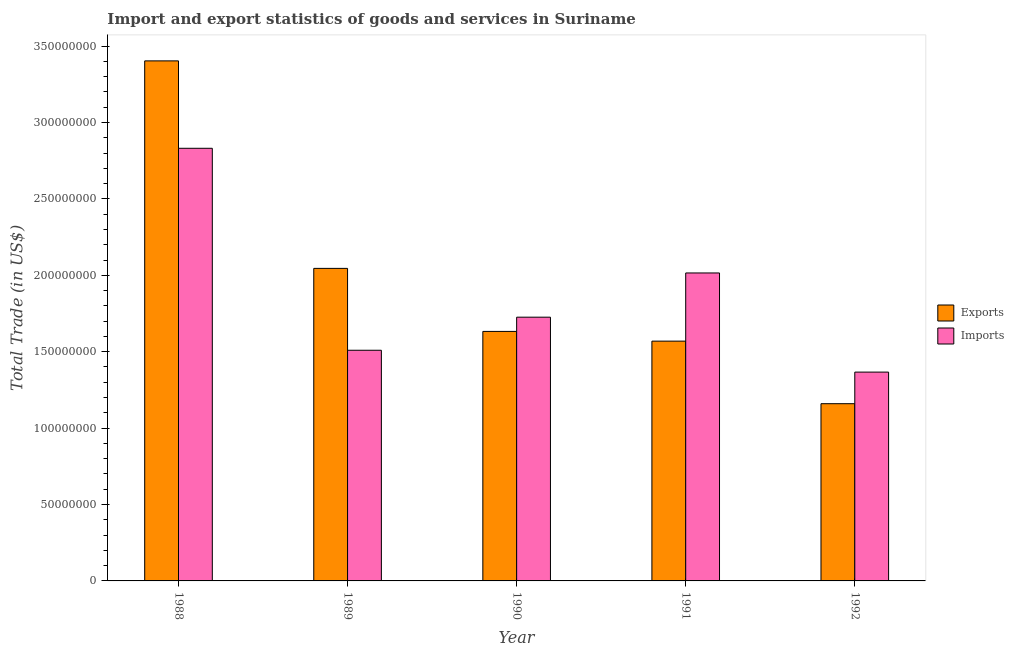How many groups of bars are there?
Your answer should be very brief. 5. Are the number of bars on each tick of the X-axis equal?
Give a very brief answer. Yes. How many bars are there on the 3rd tick from the left?
Make the answer very short. 2. What is the label of the 1st group of bars from the left?
Provide a succinct answer. 1988. In how many cases, is the number of bars for a given year not equal to the number of legend labels?
Ensure brevity in your answer.  0. What is the export of goods and services in 1989?
Your answer should be very brief. 2.05e+08. Across all years, what is the maximum imports of goods and services?
Ensure brevity in your answer.  2.83e+08. Across all years, what is the minimum imports of goods and services?
Offer a terse response. 1.37e+08. In which year was the imports of goods and services maximum?
Provide a short and direct response. 1988. What is the total imports of goods and services in the graph?
Make the answer very short. 9.45e+08. What is the difference between the export of goods and services in 1990 and that in 1991?
Provide a succinct answer. 6.36e+06. What is the difference between the export of goods and services in 1988 and the imports of goods and services in 1989?
Provide a succinct answer. 1.36e+08. What is the average export of goods and services per year?
Make the answer very short. 1.96e+08. In the year 1988, what is the difference between the imports of goods and services and export of goods and services?
Your answer should be compact. 0. In how many years, is the export of goods and services greater than 100000000 US$?
Give a very brief answer. 5. What is the ratio of the export of goods and services in 1989 to that in 1991?
Keep it short and to the point. 1.3. Is the export of goods and services in 1989 less than that in 1991?
Give a very brief answer. No. What is the difference between the highest and the second highest export of goods and services?
Ensure brevity in your answer.  1.36e+08. What is the difference between the highest and the lowest imports of goods and services?
Provide a short and direct response. 1.46e+08. In how many years, is the export of goods and services greater than the average export of goods and services taken over all years?
Your answer should be very brief. 2. Is the sum of the export of goods and services in 1988 and 1992 greater than the maximum imports of goods and services across all years?
Offer a very short reply. Yes. What does the 1st bar from the left in 1989 represents?
Your answer should be very brief. Exports. What does the 2nd bar from the right in 1988 represents?
Give a very brief answer. Exports. How many bars are there?
Ensure brevity in your answer.  10. Are all the bars in the graph horizontal?
Give a very brief answer. No. How many years are there in the graph?
Make the answer very short. 5. Are the values on the major ticks of Y-axis written in scientific E-notation?
Give a very brief answer. No. Does the graph contain grids?
Make the answer very short. No. What is the title of the graph?
Your response must be concise. Import and export statistics of goods and services in Suriname. What is the label or title of the X-axis?
Keep it short and to the point. Year. What is the label or title of the Y-axis?
Offer a very short reply. Total Trade (in US$). What is the Total Trade (in US$) of Exports in 1988?
Ensure brevity in your answer.  3.40e+08. What is the Total Trade (in US$) of Imports in 1988?
Keep it short and to the point. 2.83e+08. What is the Total Trade (in US$) in Exports in 1989?
Give a very brief answer. 2.05e+08. What is the Total Trade (in US$) in Imports in 1989?
Your answer should be very brief. 1.51e+08. What is the Total Trade (in US$) in Exports in 1990?
Your answer should be very brief. 1.63e+08. What is the Total Trade (in US$) of Imports in 1990?
Provide a short and direct response. 1.73e+08. What is the Total Trade (in US$) in Exports in 1991?
Offer a very short reply. 1.57e+08. What is the Total Trade (in US$) of Imports in 1991?
Provide a succinct answer. 2.02e+08. What is the Total Trade (in US$) of Exports in 1992?
Ensure brevity in your answer.  1.16e+08. What is the Total Trade (in US$) of Imports in 1992?
Give a very brief answer. 1.37e+08. Across all years, what is the maximum Total Trade (in US$) in Exports?
Offer a terse response. 3.40e+08. Across all years, what is the maximum Total Trade (in US$) of Imports?
Make the answer very short. 2.83e+08. Across all years, what is the minimum Total Trade (in US$) in Exports?
Your answer should be compact. 1.16e+08. Across all years, what is the minimum Total Trade (in US$) in Imports?
Give a very brief answer. 1.37e+08. What is the total Total Trade (in US$) of Exports in the graph?
Your answer should be compact. 9.81e+08. What is the total Total Trade (in US$) in Imports in the graph?
Provide a succinct answer. 9.45e+08. What is the difference between the Total Trade (in US$) in Exports in 1988 and that in 1989?
Make the answer very short. 1.36e+08. What is the difference between the Total Trade (in US$) of Imports in 1988 and that in 1989?
Your response must be concise. 1.32e+08. What is the difference between the Total Trade (in US$) in Exports in 1988 and that in 1990?
Keep it short and to the point. 1.77e+08. What is the difference between the Total Trade (in US$) of Imports in 1988 and that in 1990?
Provide a succinct answer. 1.11e+08. What is the difference between the Total Trade (in US$) in Exports in 1988 and that in 1991?
Your response must be concise. 1.83e+08. What is the difference between the Total Trade (in US$) of Imports in 1988 and that in 1991?
Your answer should be compact. 8.16e+07. What is the difference between the Total Trade (in US$) in Exports in 1988 and that in 1992?
Offer a very short reply. 2.24e+08. What is the difference between the Total Trade (in US$) of Imports in 1988 and that in 1992?
Provide a succinct answer. 1.46e+08. What is the difference between the Total Trade (in US$) in Exports in 1989 and that in 1990?
Offer a terse response. 4.12e+07. What is the difference between the Total Trade (in US$) of Imports in 1989 and that in 1990?
Your answer should be very brief. -2.16e+07. What is the difference between the Total Trade (in US$) in Exports in 1989 and that in 1991?
Provide a short and direct response. 4.76e+07. What is the difference between the Total Trade (in US$) of Imports in 1989 and that in 1991?
Your answer should be very brief. -5.06e+07. What is the difference between the Total Trade (in US$) in Exports in 1989 and that in 1992?
Give a very brief answer. 8.85e+07. What is the difference between the Total Trade (in US$) of Imports in 1989 and that in 1992?
Your answer should be very brief. 1.43e+07. What is the difference between the Total Trade (in US$) of Exports in 1990 and that in 1991?
Provide a short and direct response. 6.36e+06. What is the difference between the Total Trade (in US$) in Imports in 1990 and that in 1991?
Provide a short and direct response. -2.89e+07. What is the difference between the Total Trade (in US$) in Exports in 1990 and that in 1992?
Give a very brief answer. 4.73e+07. What is the difference between the Total Trade (in US$) of Imports in 1990 and that in 1992?
Make the answer very short. 3.59e+07. What is the difference between the Total Trade (in US$) in Exports in 1991 and that in 1992?
Offer a terse response. 4.09e+07. What is the difference between the Total Trade (in US$) of Imports in 1991 and that in 1992?
Provide a succinct answer. 6.49e+07. What is the difference between the Total Trade (in US$) in Exports in 1988 and the Total Trade (in US$) in Imports in 1989?
Offer a terse response. 1.89e+08. What is the difference between the Total Trade (in US$) in Exports in 1988 and the Total Trade (in US$) in Imports in 1990?
Give a very brief answer. 1.68e+08. What is the difference between the Total Trade (in US$) of Exports in 1988 and the Total Trade (in US$) of Imports in 1991?
Your answer should be very brief. 1.39e+08. What is the difference between the Total Trade (in US$) in Exports in 1988 and the Total Trade (in US$) in Imports in 1992?
Offer a very short reply. 2.04e+08. What is the difference between the Total Trade (in US$) of Exports in 1989 and the Total Trade (in US$) of Imports in 1990?
Ensure brevity in your answer.  3.19e+07. What is the difference between the Total Trade (in US$) in Exports in 1989 and the Total Trade (in US$) in Imports in 1991?
Make the answer very short. 3.00e+06. What is the difference between the Total Trade (in US$) of Exports in 1989 and the Total Trade (in US$) of Imports in 1992?
Give a very brief answer. 6.79e+07. What is the difference between the Total Trade (in US$) of Exports in 1990 and the Total Trade (in US$) of Imports in 1991?
Provide a short and direct response. -3.82e+07. What is the difference between the Total Trade (in US$) in Exports in 1990 and the Total Trade (in US$) in Imports in 1992?
Your answer should be compact. 2.66e+07. What is the difference between the Total Trade (in US$) in Exports in 1991 and the Total Trade (in US$) in Imports in 1992?
Offer a terse response. 2.03e+07. What is the average Total Trade (in US$) of Exports per year?
Give a very brief answer. 1.96e+08. What is the average Total Trade (in US$) of Imports per year?
Provide a short and direct response. 1.89e+08. In the year 1988, what is the difference between the Total Trade (in US$) of Exports and Total Trade (in US$) of Imports?
Your response must be concise. 5.72e+07. In the year 1989, what is the difference between the Total Trade (in US$) of Exports and Total Trade (in US$) of Imports?
Keep it short and to the point. 5.36e+07. In the year 1990, what is the difference between the Total Trade (in US$) of Exports and Total Trade (in US$) of Imports?
Provide a short and direct response. -9.31e+06. In the year 1991, what is the difference between the Total Trade (in US$) in Exports and Total Trade (in US$) in Imports?
Offer a terse response. -4.46e+07. In the year 1992, what is the difference between the Total Trade (in US$) of Exports and Total Trade (in US$) of Imports?
Ensure brevity in your answer.  -2.07e+07. What is the ratio of the Total Trade (in US$) in Exports in 1988 to that in 1989?
Give a very brief answer. 1.66. What is the ratio of the Total Trade (in US$) of Imports in 1988 to that in 1989?
Make the answer very short. 1.88. What is the ratio of the Total Trade (in US$) of Exports in 1988 to that in 1990?
Offer a very short reply. 2.08. What is the ratio of the Total Trade (in US$) of Imports in 1988 to that in 1990?
Provide a short and direct response. 1.64. What is the ratio of the Total Trade (in US$) of Exports in 1988 to that in 1991?
Offer a very short reply. 2.17. What is the ratio of the Total Trade (in US$) of Imports in 1988 to that in 1991?
Make the answer very short. 1.4. What is the ratio of the Total Trade (in US$) of Exports in 1988 to that in 1992?
Your response must be concise. 2.93. What is the ratio of the Total Trade (in US$) in Imports in 1988 to that in 1992?
Your response must be concise. 2.07. What is the ratio of the Total Trade (in US$) of Exports in 1989 to that in 1990?
Your answer should be compact. 1.25. What is the ratio of the Total Trade (in US$) of Imports in 1989 to that in 1990?
Your answer should be very brief. 0.87. What is the ratio of the Total Trade (in US$) in Exports in 1989 to that in 1991?
Make the answer very short. 1.3. What is the ratio of the Total Trade (in US$) of Imports in 1989 to that in 1991?
Give a very brief answer. 0.75. What is the ratio of the Total Trade (in US$) of Exports in 1989 to that in 1992?
Your answer should be very brief. 1.76. What is the ratio of the Total Trade (in US$) in Imports in 1989 to that in 1992?
Make the answer very short. 1.1. What is the ratio of the Total Trade (in US$) in Exports in 1990 to that in 1991?
Keep it short and to the point. 1.04. What is the ratio of the Total Trade (in US$) of Imports in 1990 to that in 1991?
Your answer should be compact. 0.86. What is the ratio of the Total Trade (in US$) of Exports in 1990 to that in 1992?
Your response must be concise. 1.41. What is the ratio of the Total Trade (in US$) of Imports in 1990 to that in 1992?
Provide a short and direct response. 1.26. What is the ratio of the Total Trade (in US$) in Exports in 1991 to that in 1992?
Provide a short and direct response. 1.35. What is the ratio of the Total Trade (in US$) in Imports in 1991 to that in 1992?
Offer a very short reply. 1.47. What is the difference between the highest and the second highest Total Trade (in US$) of Exports?
Offer a very short reply. 1.36e+08. What is the difference between the highest and the second highest Total Trade (in US$) in Imports?
Give a very brief answer. 8.16e+07. What is the difference between the highest and the lowest Total Trade (in US$) in Exports?
Your answer should be compact. 2.24e+08. What is the difference between the highest and the lowest Total Trade (in US$) in Imports?
Your response must be concise. 1.46e+08. 